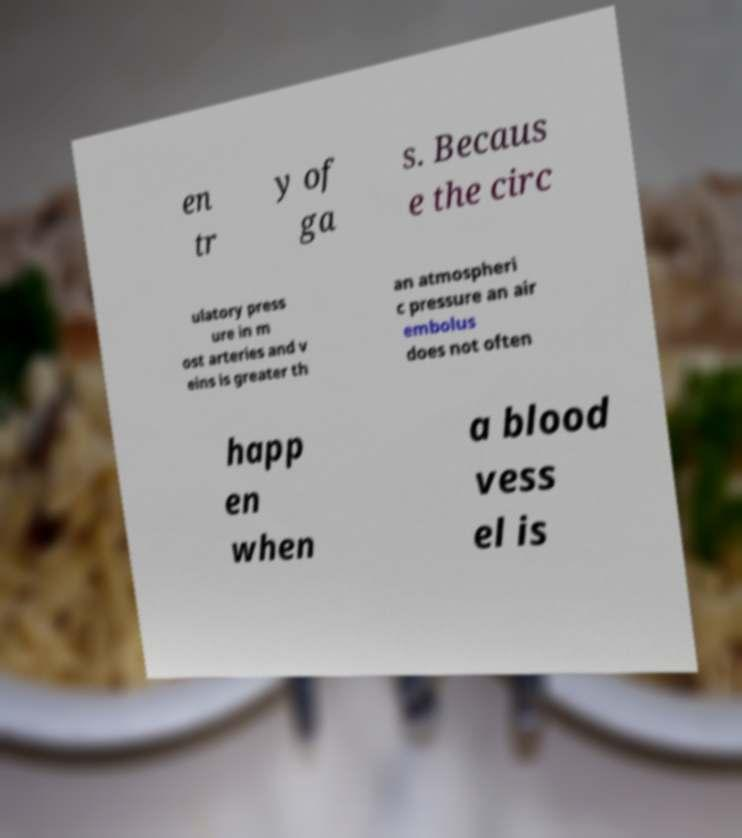Can you read and provide the text displayed in the image?This photo seems to have some interesting text. Can you extract and type it out for me? en tr y of ga s. Becaus e the circ ulatory press ure in m ost arteries and v eins is greater th an atmospheri c pressure an air embolus does not often happ en when a blood vess el is 